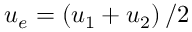<formula> <loc_0><loc_0><loc_500><loc_500>u _ { e } = \left ( u _ { 1 } + u _ { 2 } \right ) / 2</formula> 